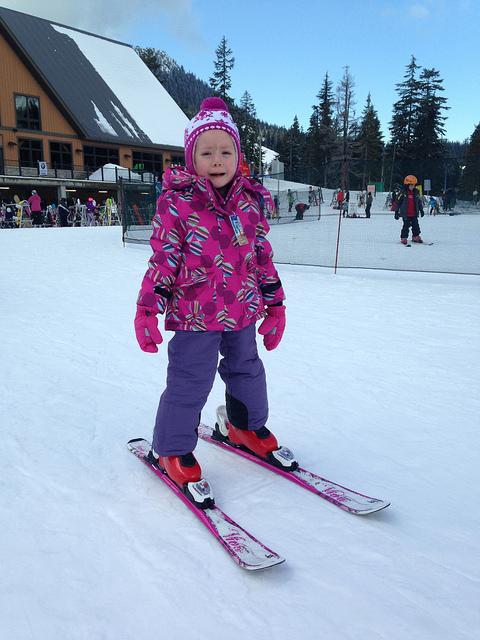Is the skier moving?
Quick response, please. No. What color is the child's jacket?
Keep it brief. Pink. What activity is the child doing?
Answer briefly. Skiing. Is this child laughing?
Be succinct. No. 